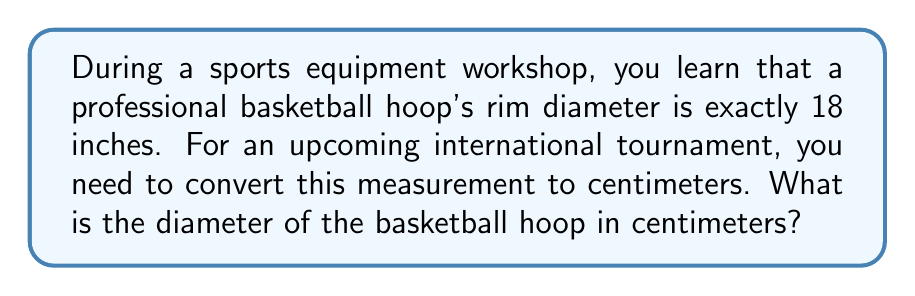Provide a solution to this math problem. To convert from inches to centimeters, we need to use the conversion factor:
1 inch = 2.54 centimeters

Let's set up the conversion:
$$ 18 \text{ inches} \times \frac{2.54 \text{ cm}}{1 \text{ inch}} $$

Now, we can perform the multiplication:
$$ 18 \times 2.54 = 45.72 \text{ cm} $$

Therefore, the diameter of the basketball hoop in centimeters is 45.72 cm.
Answer: 45.72 cm 